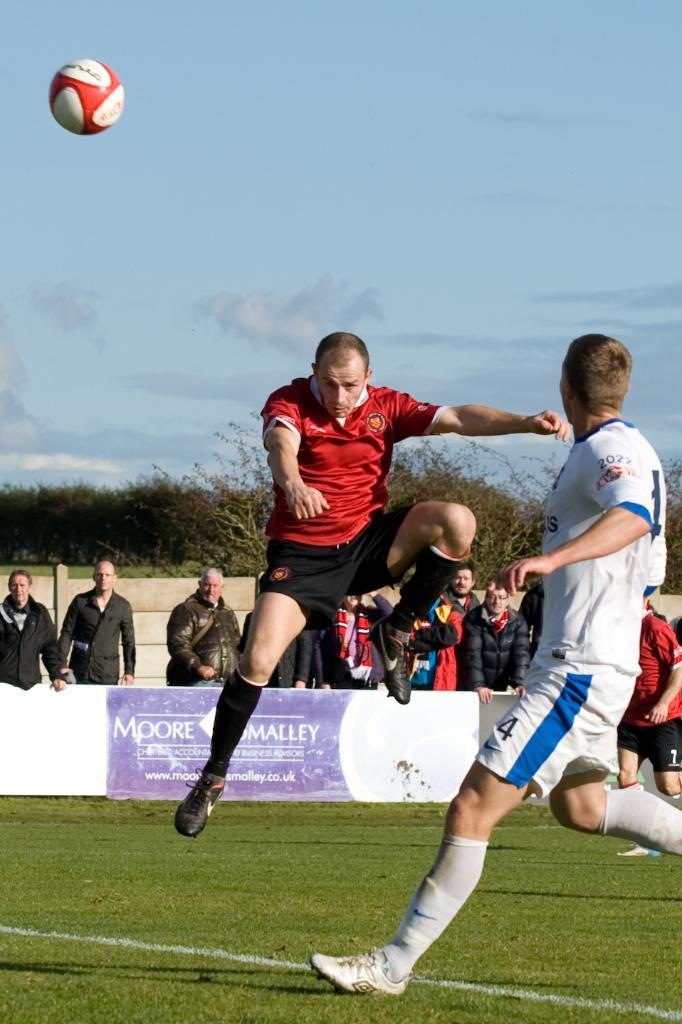Provide a one-sentence caption for the provided image. Number 4 watches his opponent who has just struck the ball. 